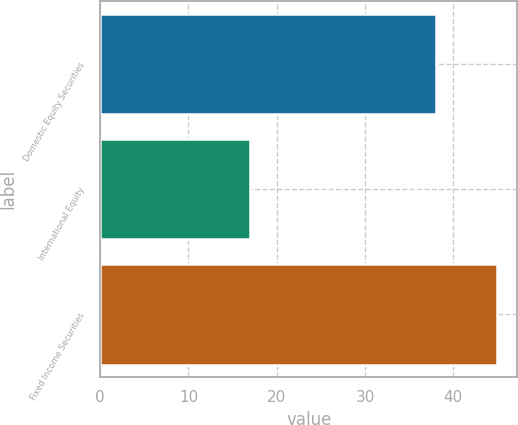Convert chart to OTSL. <chart><loc_0><loc_0><loc_500><loc_500><bar_chart><fcel>Domestic Equity Securities<fcel>International Equity<fcel>Fixed Income Securities<nl><fcel>38<fcel>17<fcel>45<nl></chart> 